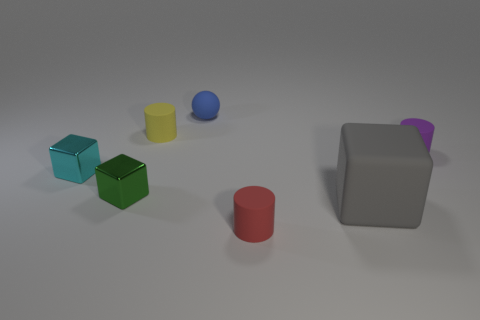Are there any other things that have the same shape as the blue object?
Your answer should be very brief. No. What shape is the tiny object that is in front of the small cyan thing and behind the small red cylinder?
Your answer should be compact. Cube. Are there any rubber spheres that are right of the cylinder that is on the left side of the blue rubber sphere?
Your answer should be very brief. Yes. What number of other objects are there of the same material as the tiny ball?
Make the answer very short. 4. Is the shape of the small metallic object that is right of the cyan shiny thing the same as the small rubber thing in front of the small green object?
Your answer should be very brief. No. Are the tiny green cube and the purple cylinder made of the same material?
Offer a terse response. No. There is a cube that is right of the small rubber object in front of the metallic thing to the right of the cyan thing; how big is it?
Your response must be concise. Large. How many other things are the same color as the rubber cube?
Keep it short and to the point. 0. What shape is the purple matte thing that is the same size as the red matte object?
Give a very brief answer. Cylinder. How many big objects are metal things or rubber cylinders?
Keep it short and to the point. 0. 